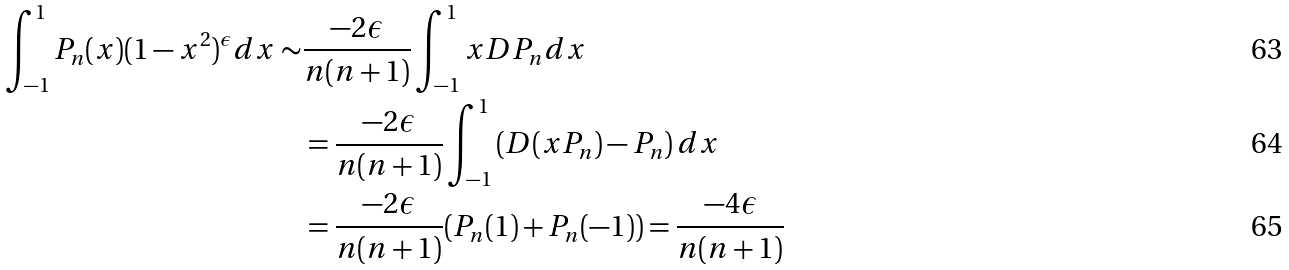<formula> <loc_0><loc_0><loc_500><loc_500>\int _ { - 1 } ^ { 1 } P _ { n } ( x ) ( 1 - x ^ { 2 } ) ^ { \epsilon } d x \sim & \frac { - 2 \epsilon } { n ( n + 1 ) } \int _ { - 1 } ^ { 1 } x D P _ { n } d x \\ & = \frac { - 2 \epsilon } { n ( n + 1 ) } \int _ { - 1 } ^ { 1 } \left ( D ( x P _ { n } ) - P _ { n } \right ) d x \\ & = \frac { - 2 \epsilon } { n ( n + 1 ) } ( P _ { n } ( 1 ) + P _ { n } ( - 1 ) ) = \frac { - 4 \epsilon } { n ( n + 1 ) }</formula> 